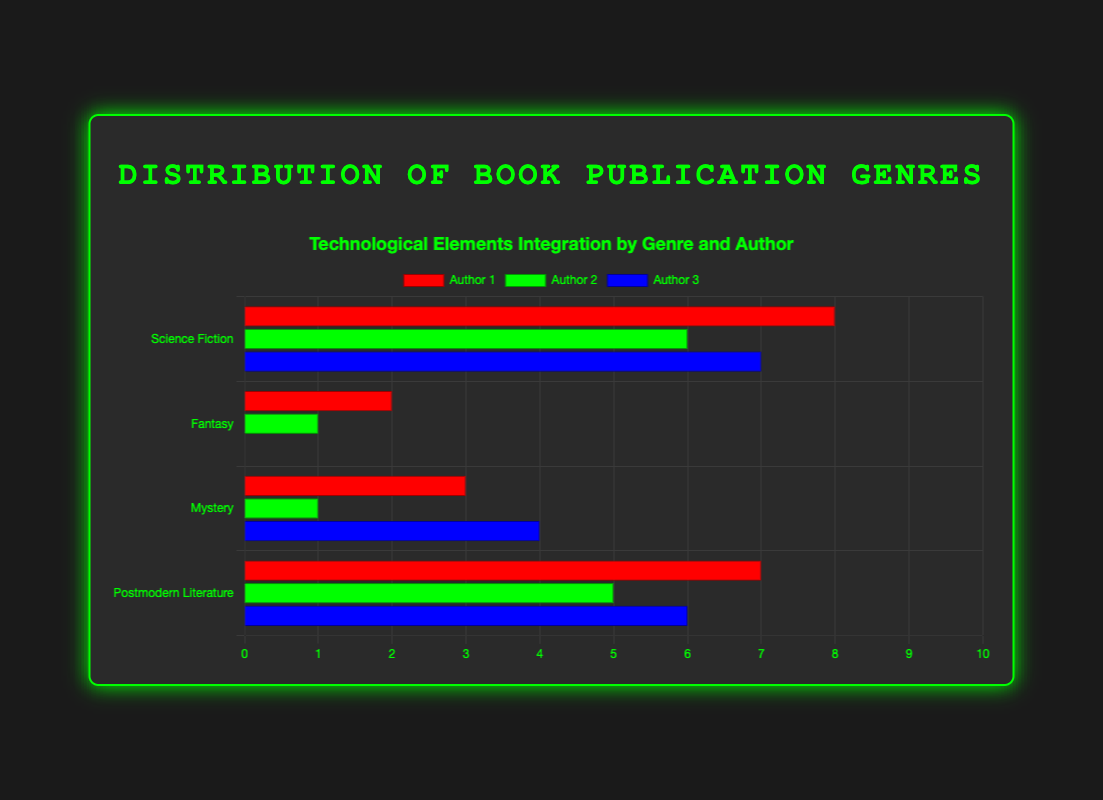Which genre has the highest average number of technological elements integrated by authors? To find the average number of technological elements for each genre, sum up the values for each author in the genre and divide by the number of authors. For Science Fiction: (8+6+7)/3 = 21/3 = 7; For Fantasy: (2+1+0)/3 = 3/3 = 1; For Mystery: (3+1+4)/3 = 8/3 ≈ 2.67; For Postmodern Literature: (7+5+6)/3 = 18/3 = 6. Hence, Science Fiction has the highest average.
Answer: Science Fiction Which individual author integrates the most technological elements? Compare the technological elements integrated by each author: Isaac Asimov (8), Philip K. Dick (6), Ursula K. Le Guin (7), J.K. Rowling (2), George R.R. Martin (1), J.R.R. Tolkien (0), Agatha Christie (3), Arthur Conan Doyle (1), Gillian Flynn (4), Thomas Pynchon (7), Kurt Vonnegut (5), Don DeLillo (6). Isaac Asimov integrates the most with 8 elements.
Answer: Isaac Asimov How many technological elements, in total, are integrated by European authors in the Mystery genre? The authors from Europe in the Mystery genre are Agatha Christie and Arthur Conan Doyle. Their technological elements are 3 and 1 respectively. Sum them up: 3 + 1 = 4.
Answer: 4 What is the difference between the highest and lowest number of technological elements integrated by authors in Fantasy? The numbers of technological elements in Fantasy are 2 (J.K. Rowling), 1 (George R.R. Martin), and 0 (J.R.R. Tolkien). The highest number is 2, and the lowest is 0. The difference is 2 - 0 = 2.
Answer: 2 Which author in the Postmodern Literature genre uses fewer technological elements than Don DeLillo? In Postmodern Literature, compare Don DeLillo's technological elements (6) with those of Thomas Pynchon (7) and Kurt Vonnegut (5). Kurt Vonnegut integrates fewer elements (5).
Answer: Kurt Vonnegut Compare the average age of authors in Mystery and Postmodern Literature. Which genre has older authors on average? For Mystery: (65+60+46)/3 ≈ 57; For Postmodern Literature: (54+59+65)/3 ≈ 59.33. Postmodern Literature authors are older on average.
Answer: Postmodern Literature How many more technological elements are integrated by Ursula K. Le Guin compared to J.K. Rowling? Ursula K. Le Guin integrates 7 elements, while J.K. Rowling integrates 2. The difference is 7 - 2 = 5.
Answer: 5 How does the color-coded representation in the chart help in identifying authors with similar levels of technological integration? The chart uses distinct colors for each author within a genre, allowing easy visual comparison across genres by color. Authors with similar levels of technological integration might have bars of similar length, which can be quickly assessed through color differentiation.
Answer: Distinct colors and bar lengths 